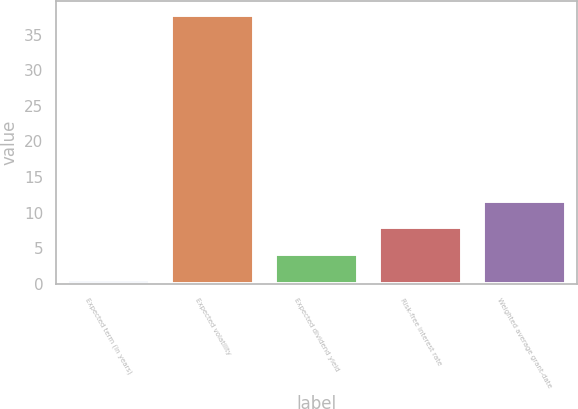Convert chart. <chart><loc_0><loc_0><loc_500><loc_500><bar_chart><fcel>Expected term (in years)<fcel>Expected volatility<fcel>Expected dividend yield<fcel>Risk-free interest rate<fcel>Weighted average grant-date<nl><fcel>0.5<fcel>37.77<fcel>4.23<fcel>7.96<fcel>11.69<nl></chart> 